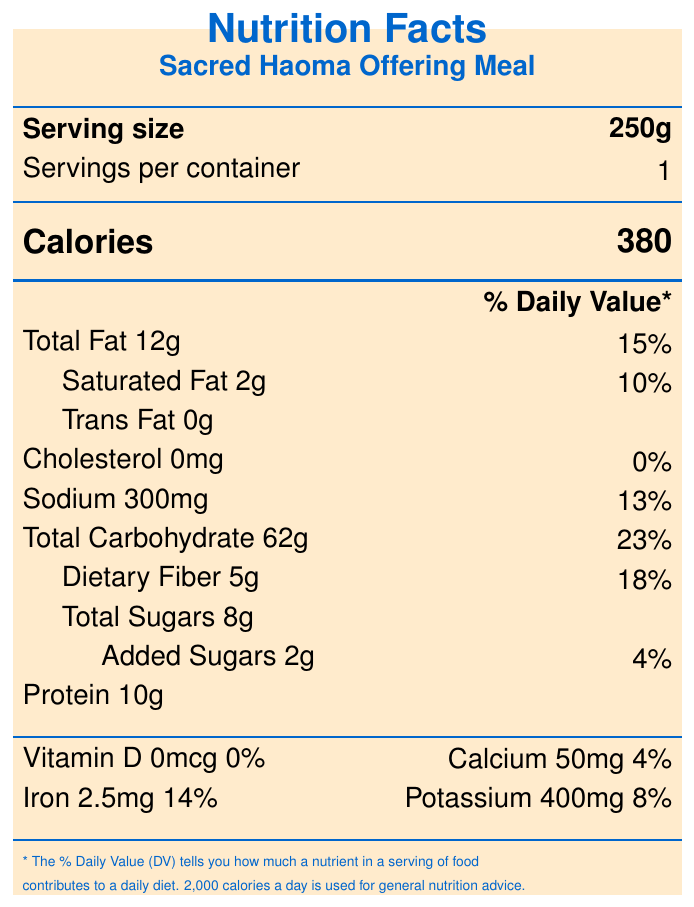what is the serving size? The serving size is clearly indicated in the section titled "Serving size."
Answer: 250g how many servings are in one container? Just below the serving size, it states "Servings per container 1."
Answer: 1 how many calories are in one serving? Under the "Calories" section, it clearly states "Calories 380."
Answer: 380 What is the amount of total fat per serving? The "Total Fat" amount is listed as 12g in the nutrients table.
Answer: 12g What is the dietary fiber content in one serving? The dietary fiber content is listed as 5g in the nutrients table.
Answer: 5g How much cholesterol is in the Sacred Haoma Offering Meal? The cholesterol amount is clearly stated as 0mg.
Answer: 0mg What is the percent daily value of iron? The percent daily value of iron is listed as 14%.
Answer: 14% What is the total carbohydrate content in one serving? A. 50g B. 62g C. 70g The total carbohydrate content is given as 62g in the nutrients table.
Answer: B Which nutrient has the highest percent daily value? A. Saturated Fat B. Dietary Fiber C. Total Carbohydrate The total carbohydrate has the highest percent daily value of 23%.
Answer: C Does the Sacred Haoma Offering Meal contain any trans fat? The document lists "Trans Fat 0g,” which means it does not contain trans fat.
Answer: No Summarize the main idea of the document. The main idea of the document is to provide detailed nutritional information about the Sacred Haoma Offering Meal, including its ingredients and religious importance.
Answer: The document is a Nutrition Facts label for the "Sacred Haoma Offering Meal," detailing the nutritional content per 250g serving. It includes information on calories, fats, cholesterol, sodium, carbohydrates, protein, vitamins, and minerals, as well as a list of ingredients and allergen info. The meal has significant religious significance and is prepared in accordance with Zoroastrian dietary laws. How much potassium is in the Sacred Haoma Offering Meal? The potassium content is listed as 400mg in the vitamins and minerals section.
Answer: 400mg What symbol is used to represent prosperity and nourishment in the ingredients list? According to the religious significance section, barley symbolizes prosperity and nourishment.
Answer: Barley Is the Sacred Haoma Offering Meal certified by any organization? The meal is certified by the World Zoroastrian Organization and prepared in a consecrated fire temple kitchen.
Answer: Yes How many grams of added sugars are in one serving? The nutrients table lists "Added Sugars 2g."
Answer: 2g What are the primary allergens present in the Sacred Haoma Offering Meal? The allergen info specifies that the meal contains tree nuts, specifically pistachios.
Answer: Tree Nuts (Pistachios) What impact does the Sacred Haoma Offering Meal have on a 2,000 calorie diet based on its percent daily values? The Nutrition Facts label provides the percent daily values for individual nutrients, but to determine the overall impact on a 2,000 calorie diet, a more comprehensive dietary analysis is needed.
Answer: Cannot be determined How much saturated fat is in one serving of the Sacred Haoma Offering Meal? The saturated fat content is listed as 2g in the nutrients table.
Answer: 2g 